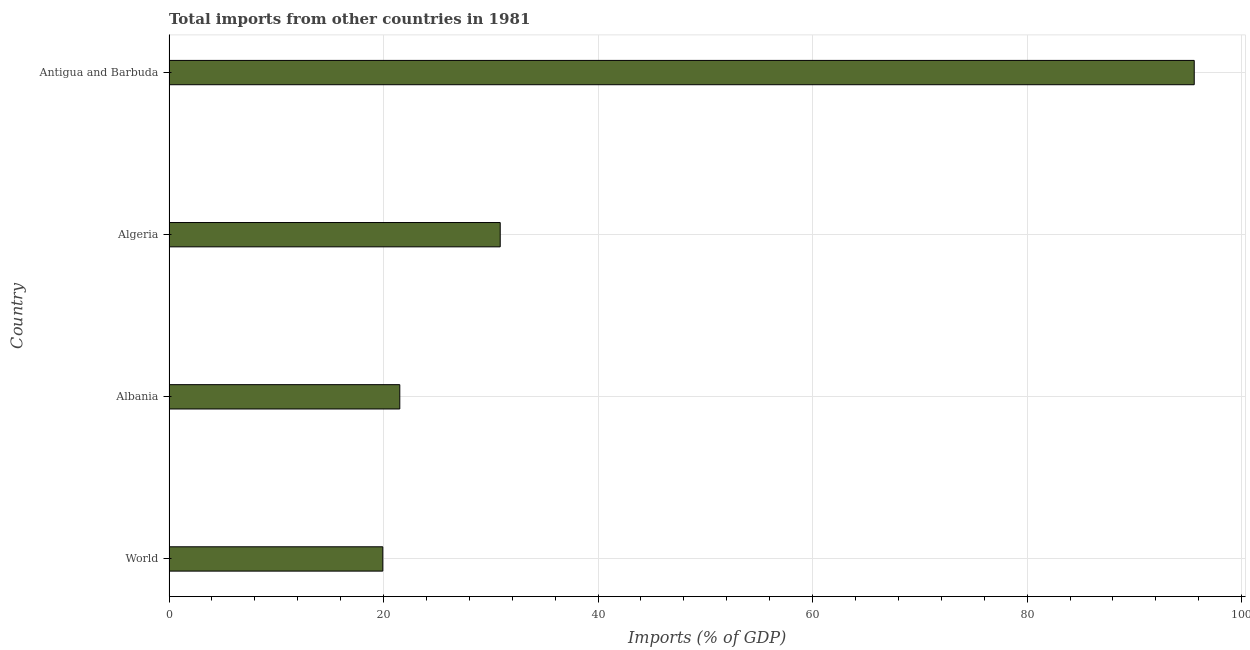What is the title of the graph?
Offer a very short reply. Total imports from other countries in 1981. What is the label or title of the X-axis?
Give a very brief answer. Imports (% of GDP). What is the label or title of the Y-axis?
Give a very brief answer. Country. What is the total imports in Antigua and Barbuda?
Offer a very short reply. 95.58. Across all countries, what is the maximum total imports?
Your answer should be very brief. 95.58. Across all countries, what is the minimum total imports?
Your answer should be very brief. 19.93. In which country was the total imports maximum?
Ensure brevity in your answer.  Antigua and Barbuda. In which country was the total imports minimum?
Offer a terse response. World. What is the sum of the total imports?
Provide a succinct answer. 167.9. What is the difference between the total imports in Algeria and Antigua and Barbuda?
Offer a terse response. -64.7. What is the average total imports per country?
Your response must be concise. 41.98. What is the median total imports?
Offer a terse response. 26.2. In how many countries, is the total imports greater than 88 %?
Make the answer very short. 1. What is the ratio of the total imports in Albania to that in World?
Ensure brevity in your answer.  1.08. Is the total imports in Algeria less than that in World?
Your answer should be very brief. No. Is the difference between the total imports in Albania and Antigua and Barbuda greater than the difference between any two countries?
Ensure brevity in your answer.  No. What is the difference between the highest and the second highest total imports?
Offer a very short reply. 64.7. Is the sum of the total imports in Antigua and Barbuda and World greater than the maximum total imports across all countries?
Give a very brief answer. Yes. What is the difference between the highest and the lowest total imports?
Offer a terse response. 75.64. How many bars are there?
Offer a very short reply. 4. Are all the bars in the graph horizontal?
Your answer should be very brief. Yes. What is the difference between two consecutive major ticks on the X-axis?
Provide a succinct answer. 20. What is the Imports (% of GDP) in World?
Your answer should be very brief. 19.93. What is the Imports (% of GDP) in Albania?
Make the answer very short. 21.51. What is the Imports (% of GDP) in Algeria?
Provide a short and direct response. 30.88. What is the Imports (% of GDP) of Antigua and Barbuda?
Give a very brief answer. 95.58. What is the difference between the Imports (% of GDP) in World and Albania?
Ensure brevity in your answer.  -1.58. What is the difference between the Imports (% of GDP) in World and Algeria?
Make the answer very short. -10.95. What is the difference between the Imports (% of GDP) in World and Antigua and Barbuda?
Offer a very short reply. -75.64. What is the difference between the Imports (% of GDP) in Albania and Algeria?
Your answer should be very brief. -9.36. What is the difference between the Imports (% of GDP) in Albania and Antigua and Barbuda?
Offer a terse response. -74.06. What is the difference between the Imports (% of GDP) in Algeria and Antigua and Barbuda?
Your answer should be very brief. -64.7. What is the ratio of the Imports (% of GDP) in World to that in Albania?
Your answer should be very brief. 0.93. What is the ratio of the Imports (% of GDP) in World to that in Algeria?
Offer a very short reply. 0.65. What is the ratio of the Imports (% of GDP) in World to that in Antigua and Barbuda?
Give a very brief answer. 0.21. What is the ratio of the Imports (% of GDP) in Albania to that in Algeria?
Your response must be concise. 0.7. What is the ratio of the Imports (% of GDP) in Albania to that in Antigua and Barbuda?
Your answer should be compact. 0.23. What is the ratio of the Imports (% of GDP) in Algeria to that in Antigua and Barbuda?
Your response must be concise. 0.32. 